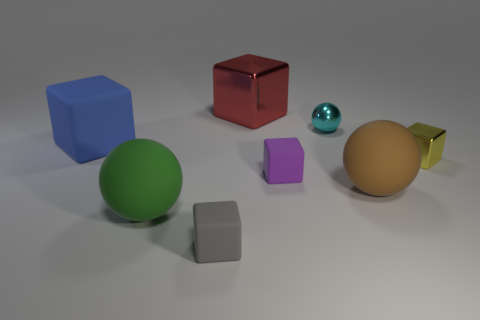What is the size of the brown matte ball? The brown matte ball appears to be medium-sized in relation to the other objects in the image, such as the large green sphere and the small purple cube. 